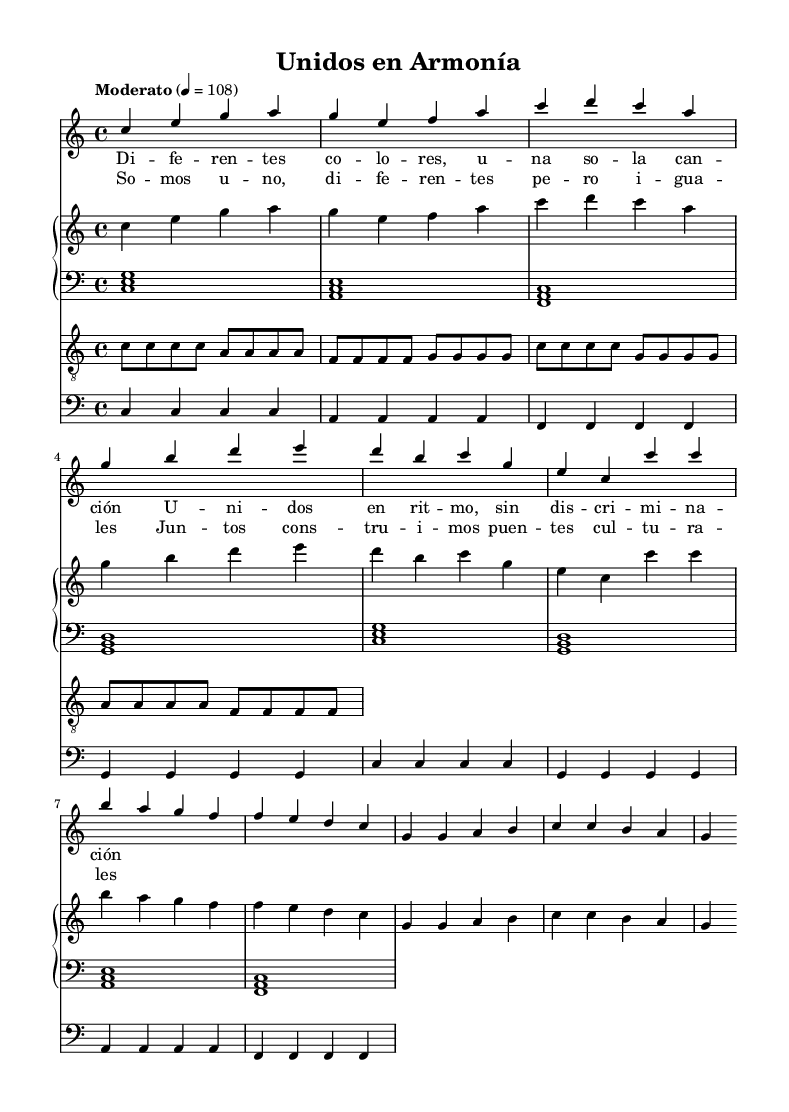What is the key signature of this music? The key signature is C major, which has no sharps or flats.
Answer: C major What is the time signature of the piece? The time signature is indicated by the numeral above the staff, which shows it is in 4/4 time, meaning there are four beats in each measure.
Answer: 4/4 What is the tempo marking of the piece? The tempo marking indicates "Moderato" with a metronome mark of 108, suggesting a moderate speed.
Answer: Moderato How many measures are there in the verse? The verse consists of four measures, as observed from the music notation for the verse section.
Answer: Four What is the main theme of the lyrics? The lyrics promote unity and acceptance among different cultures, as indicated by the phrases used in the verse and chorus.
Answer: Unity How many different instrument parts are included in the score? The score includes four different instrumental parts: voice, piano, guitar, and bass, which contribute to the overall arrangement.
Answer: Four What is the significance of the lyrics "Unidos en ritmo"? The phrase “Unidos en ritmo” translates to “United in rhythm,” symbolizing harmony and the coming together of diverse cultures through music.
Answer: Harmony 